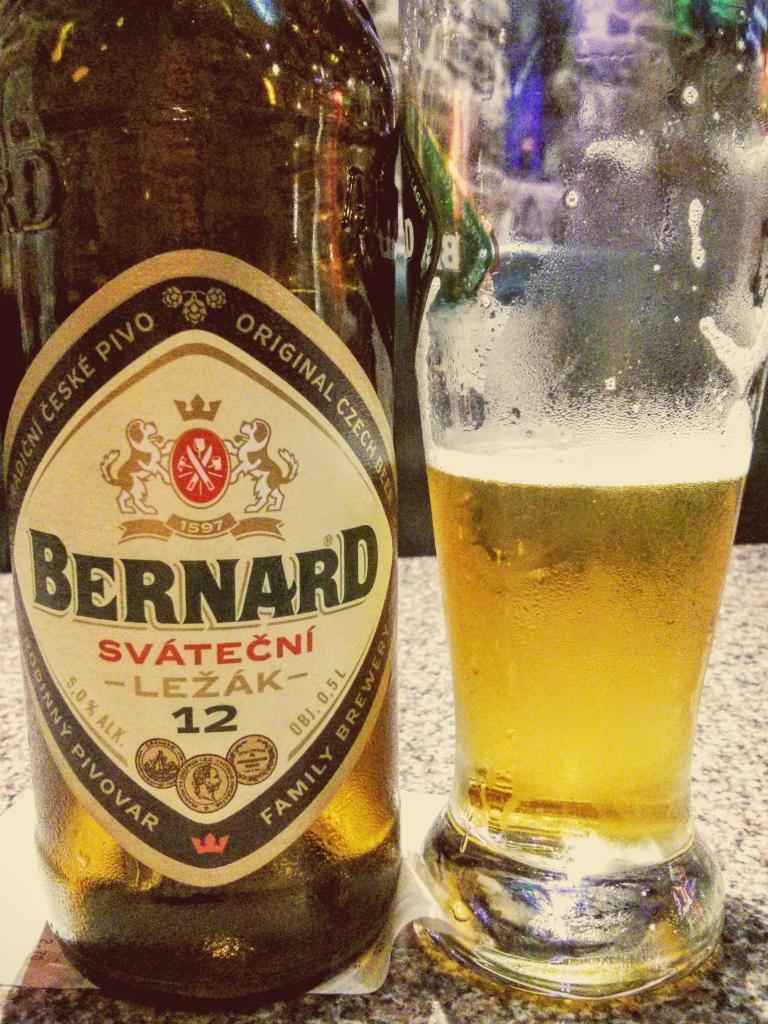Provide a one-sentence caption for the provided image. a bottle that has the word Bernard on it. 